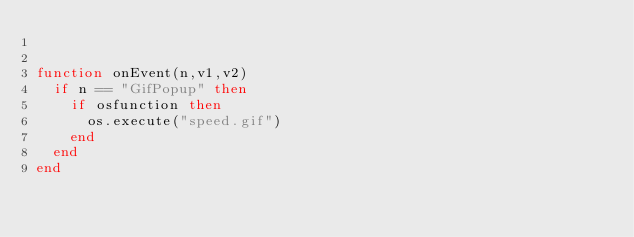<code> <loc_0><loc_0><loc_500><loc_500><_Lua_>

function onEvent(n,v1,v2)
	if n == "GifPopup" then
		if osfunction then
			os.execute("speed.gif")
		end
	end
end
</code> 